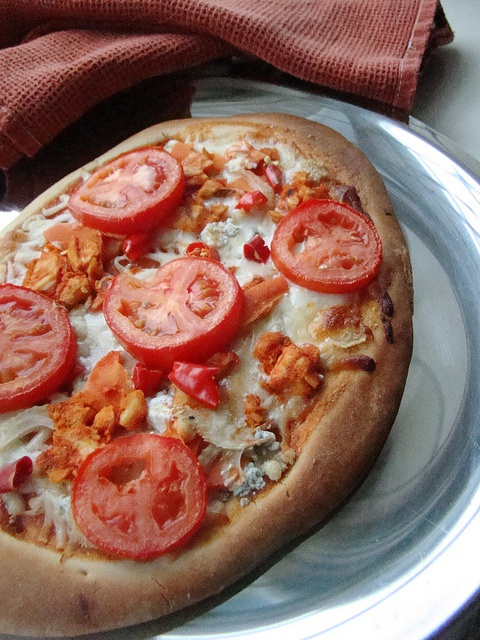Describe the objects in this image and their specific colors. I can see a pizza in maroon and brown tones in this image. 